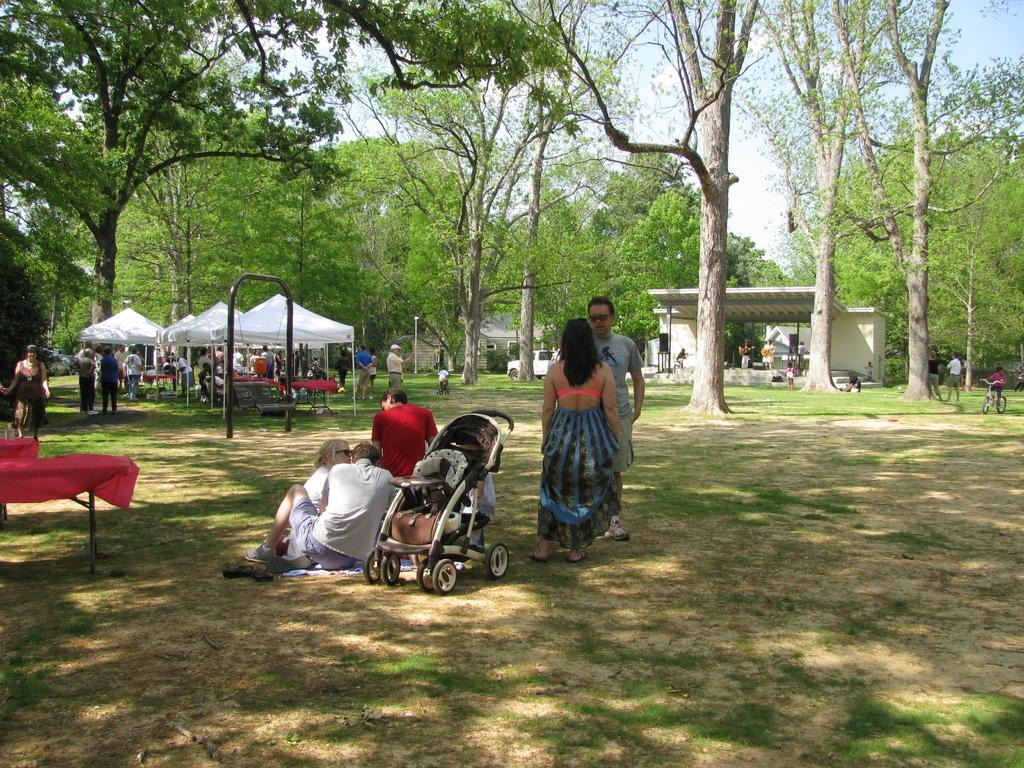What is the main feature of the landscape in the image? There are many trees in the image. What are the people doing in the image? Some people are standing under a tent, while others are sitting on the ground. What object is near the people sitting on the ground? There is a trolley near the people sitting on the ground. What structure is present for performances or events? There is a stage in the image. What type of transportation is visible in the image? There is a vehicle in the image. Can you see a mountain in the background of the image? There is no mountain visible in the image; it features trees, people, and various objects and structures. 